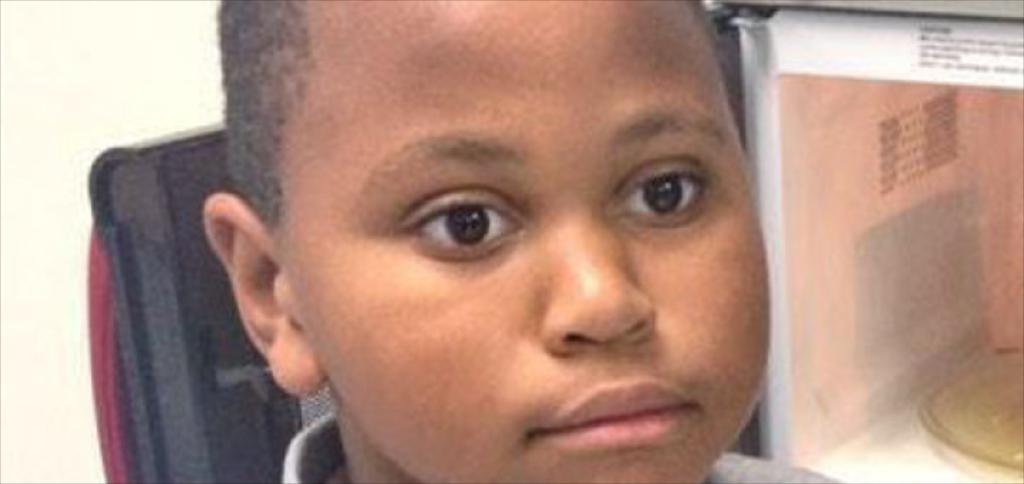Describe this image in one or two sentences. In this picture I can see a boy and a microwave oven on the right side and its door is opened. 